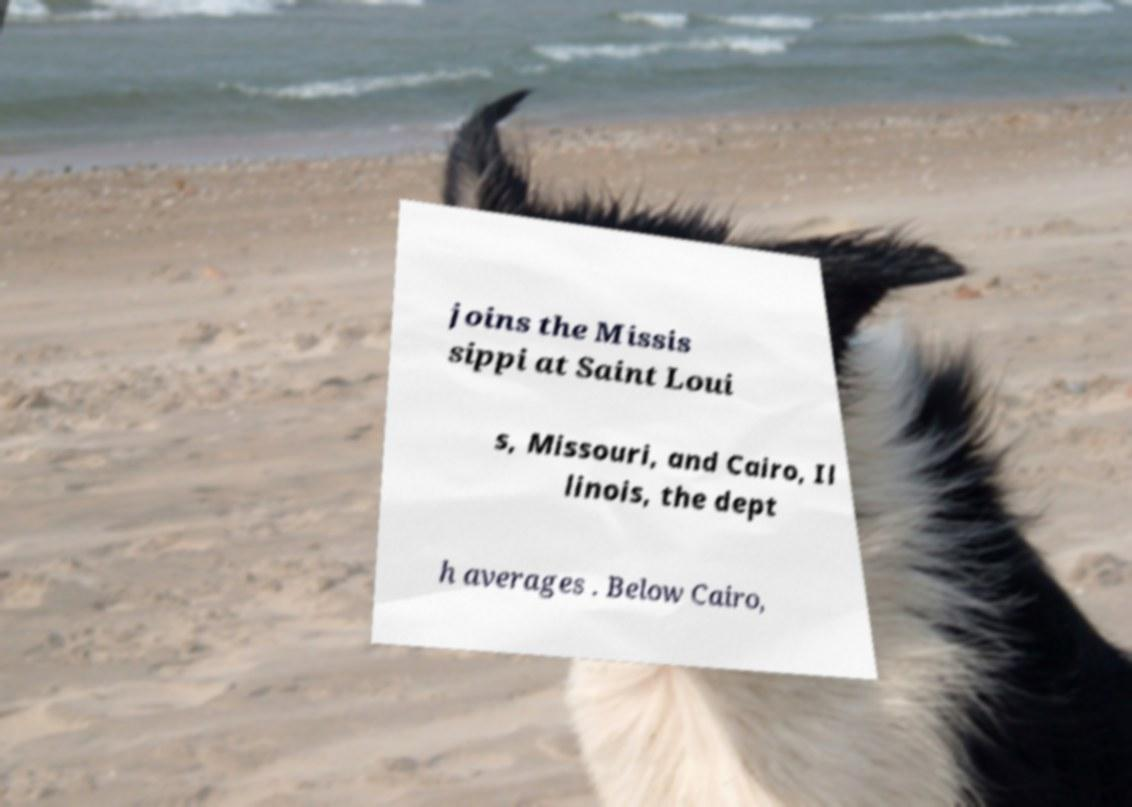Please identify and transcribe the text found in this image. joins the Missis sippi at Saint Loui s, Missouri, and Cairo, Il linois, the dept h averages . Below Cairo, 